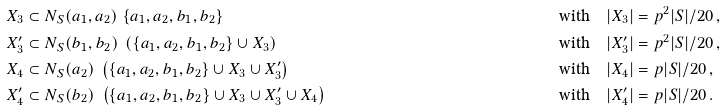<formula> <loc_0><loc_0><loc_500><loc_500>X _ { 3 } & \subset N _ { S } ( a _ { 1 } , a _ { 2 } ) \ \{ a _ { 1 } , a _ { 2 } , b _ { 1 } , b _ { 2 } \} & \quad \text {with} \quad | X _ { 3 } | & = p ^ { 2 } | S | / 2 0 \, , \\ X ^ { \prime } _ { 3 } & \subset N _ { S } ( b _ { 1 } , b _ { 2 } ) \ \left ( \{ a _ { 1 } , a _ { 2 } , b _ { 1 } , b _ { 2 } \} \cup X _ { 3 } \right ) & \quad \text {with} \quad | X ^ { \prime } _ { 3 } | & = p ^ { 2 } | S | / 2 0 \, , \\ X _ { 4 } & \subset N _ { S } ( a _ { 2 } ) \ \left ( \{ a _ { 1 } , a _ { 2 } , b _ { 1 } , b _ { 2 } \} \cup X _ { 3 } \cup X ^ { \prime } _ { 3 } \right ) & \quad \text {with} \quad | X _ { 4 } | & = p | S | / 2 0 \, , \\ X ^ { \prime } _ { 4 } & \subset N _ { S } ( b _ { 2 } ) \ \left ( \{ a _ { 1 } , a _ { 2 } , b _ { 1 } , b _ { 2 } \} \cup X _ { 3 } \cup X ^ { \prime } _ { 3 } \cup X _ { 4 } \right ) & \quad \text {with} \quad | X ^ { \prime } _ { 4 } | & = p | S | / 2 0 \, .</formula> 